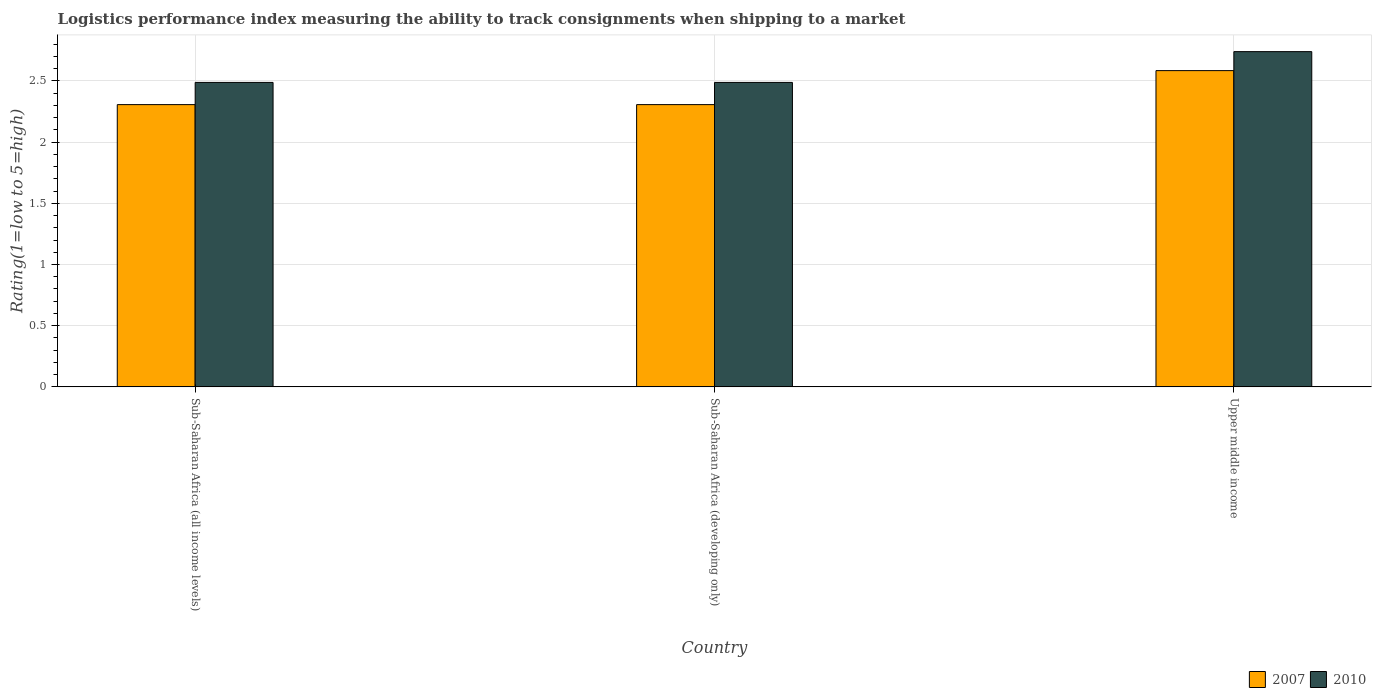How many groups of bars are there?
Make the answer very short. 3. What is the label of the 3rd group of bars from the left?
Your response must be concise. Upper middle income. In how many cases, is the number of bars for a given country not equal to the number of legend labels?
Keep it short and to the point. 0. What is the Logistic performance index in 2007 in Upper middle income?
Give a very brief answer. 2.58. Across all countries, what is the maximum Logistic performance index in 2007?
Offer a terse response. 2.58. Across all countries, what is the minimum Logistic performance index in 2010?
Provide a succinct answer. 2.49. In which country was the Logistic performance index in 2007 maximum?
Your response must be concise. Upper middle income. In which country was the Logistic performance index in 2007 minimum?
Make the answer very short. Sub-Saharan Africa (all income levels). What is the total Logistic performance index in 2007 in the graph?
Keep it short and to the point. 7.2. What is the difference between the Logistic performance index in 2010 in Sub-Saharan Africa (all income levels) and that in Upper middle income?
Your answer should be very brief. -0.25. What is the difference between the Logistic performance index in 2010 in Upper middle income and the Logistic performance index in 2007 in Sub-Saharan Africa (developing only)?
Provide a succinct answer. 0.43. What is the average Logistic performance index in 2010 per country?
Give a very brief answer. 2.57. What is the difference between the Logistic performance index of/in 2010 and Logistic performance index of/in 2007 in Sub-Saharan Africa (all income levels)?
Provide a succinct answer. 0.18. In how many countries, is the Logistic performance index in 2007 greater than 1.5?
Your response must be concise. 3. What is the ratio of the Logistic performance index in 2010 in Sub-Saharan Africa (all income levels) to that in Upper middle income?
Make the answer very short. 0.91. Is the Logistic performance index in 2010 in Sub-Saharan Africa (developing only) less than that in Upper middle income?
Offer a very short reply. Yes. Is the difference between the Logistic performance index in 2010 in Sub-Saharan Africa (all income levels) and Upper middle income greater than the difference between the Logistic performance index in 2007 in Sub-Saharan Africa (all income levels) and Upper middle income?
Give a very brief answer. Yes. What is the difference between the highest and the second highest Logistic performance index in 2007?
Offer a terse response. 0.28. What is the difference between the highest and the lowest Logistic performance index in 2007?
Offer a very short reply. 0.28. In how many countries, is the Logistic performance index in 2010 greater than the average Logistic performance index in 2010 taken over all countries?
Keep it short and to the point. 1. Is the sum of the Logistic performance index in 2007 in Sub-Saharan Africa (all income levels) and Upper middle income greater than the maximum Logistic performance index in 2010 across all countries?
Ensure brevity in your answer.  Yes. What does the 2nd bar from the left in Upper middle income represents?
Offer a very short reply. 2010. What does the 1st bar from the right in Sub-Saharan Africa (developing only) represents?
Make the answer very short. 2010. How many bars are there?
Your answer should be compact. 6. Are all the bars in the graph horizontal?
Keep it short and to the point. No. How many countries are there in the graph?
Make the answer very short. 3. What is the difference between two consecutive major ticks on the Y-axis?
Keep it short and to the point. 0.5. Does the graph contain any zero values?
Provide a short and direct response. No. Does the graph contain grids?
Make the answer very short. Yes. How are the legend labels stacked?
Provide a succinct answer. Horizontal. What is the title of the graph?
Your answer should be compact. Logistics performance index measuring the ability to track consignments when shipping to a market. Does "1977" appear as one of the legend labels in the graph?
Provide a succinct answer. No. What is the label or title of the X-axis?
Your answer should be very brief. Country. What is the label or title of the Y-axis?
Keep it short and to the point. Rating(1=low to 5=high). What is the Rating(1=low to 5=high) in 2007 in Sub-Saharan Africa (all income levels)?
Provide a short and direct response. 2.31. What is the Rating(1=low to 5=high) in 2010 in Sub-Saharan Africa (all income levels)?
Keep it short and to the point. 2.49. What is the Rating(1=low to 5=high) of 2007 in Sub-Saharan Africa (developing only)?
Your answer should be compact. 2.31. What is the Rating(1=low to 5=high) in 2010 in Sub-Saharan Africa (developing only)?
Provide a succinct answer. 2.49. What is the Rating(1=low to 5=high) in 2007 in Upper middle income?
Give a very brief answer. 2.58. What is the Rating(1=low to 5=high) of 2010 in Upper middle income?
Your answer should be very brief. 2.74. Across all countries, what is the maximum Rating(1=low to 5=high) of 2007?
Give a very brief answer. 2.58. Across all countries, what is the maximum Rating(1=low to 5=high) of 2010?
Provide a short and direct response. 2.74. Across all countries, what is the minimum Rating(1=low to 5=high) in 2007?
Your answer should be compact. 2.31. Across all countries, what is the minimum Rating(1=low to 5=high) in 2010?
Your answer should be very brief. 2.49. What is the total Rating(1=low to 5=high) in 2007 in the graph?
Your response must be concise. 7.2. What is the total Rating(1=low to 5=high) in 2010 in the graph?
Give a very brief answer. 7.71. What is the difference between the Rating(1=low to 5=high) of 2007 in Sub-Saharan Africa (all income levels) and that in Sub-Saharan Africa (developing only)?
Provide a short and direct response. 0. What is the difference between the Rating(1=low to 5=high) in 2010 in Sub-Saharan Africa (all income levels) and that in Sub-Saharan Africa (developing only)?
Your answer should be compact. 0. What is the difference between the Rating(1=low to 5=high) in 2007 in Sub-Saharan Africa (all income levels) and that in Upper middle income?
Your response must be concise. -0.28. What is the difference between the Rating(1=low to 5=high) in 2010 in Sub-Saharan Africa (all income levels) and that in Upper middle income?
Offer a very short reply. -0.25. What is the difference between the Rating(1=low to 5=high) of 2007 in Sub-Saharan Africa (developing only) and that in Upper middle income?
Your response must be concise. -0.28. What is the difference between the Rating(1=low to 5=high) of 2010 in Sub-Saharan Africa (developing only) and that in Upper middle income?
Make the answer very short. -0.25. What is the difference between the Rating(1=low to 5=high) of 2007 in Sub-Saharan Africa (all income levels) and the Rating(1=low to 5=high) of 2010 in Sub-Saharan Africa (developing only)?
Offer a very short reply. -0.18. What is the difference between the Rating(1=low to 5=high) of 2007 in Sub-Saharan Africa (all income levels) and the Rating(1=low to 5=high) of 2010 in Upper middle income?
Make the answer very short. -0.43. What is the difference between the Rating(1=low to 5=high) of 2007 in Sub-Saharan Africa (developing only) and the Rating(1=low to 5=high) of 2010 in Upper middle income?
Your answer should be compact. -0.43. What is the average Rating(1=low to 5=high) of 2007 per country?
Keep it short and to the point. 2.4. What is the average Rating(1=low to 5=high) of 2010 per country?
Keep it short and to the point. 2.57. What is the difference between the Rating(1=low to 5=high) of 2007 and Rating(1=low to 5=high) of 2010 in Sub-Saharan Africa (all income levels)?
Provide a succinct answer. -0.18. What is the difference between the Rating(1=low to 5=high) in 2007 and Rating(1=low to 5=high) in 2010 in Sub-Saharan Africa (developing only)?
Your answer should be very brief. -0.18. What is the difference between the Rating(1=low to 5=high) of 2007 and Rating(1=low to 5=high) of 2010 in Upper middle income?
Offer a terse response. -0.16. What is the ratio of the Rating(1=low to 5=high) in 2007 in Sub-Saharan Africa (all income levels) to that in Sub-Saharan Africa (developing only)?
Provide a succinct answer. 1. What is the ratio of the Rating(1=low to 5=high) of 2010 in Sub-Saharan Africa (all income levels) to that in Sub-Saharan Africa (developing only)?
Your answer should be compact. 1. What is the ratio of the Rating(1=low to 5=high) of 2007 in Sub-Saharan Africa (all income levels) to that in Upper middle income?
Offer a terse response. 0.89. What is the ratio of the Rating(1=low to 5=high) in 2010 in Sub-Saharan Africa (all income levels) to that in Upper middle income?
Offer a very short reply. 0.91. What is the ratio of the Rating(1=low to 5=high) in 2007 in Sub-Saharan Africa (developing only) to that in Upper middle income?
Your answer should be compact. 0.89. What is the ratio of the Rating(1=low to 5=high) in 2010 in Sub-Saharan Africa (developing only) to that in Upper middle income?
Make the answer very short. 0.91. What is the difference between the highest and the second highest Rating(1=low to 5=high) in 2007?
Offer a terse response. 0.28. What is the difference between the highest and the second highest Rating(1=low to 5=high) in 2010?
Make the answer very short. 0.25. What is the difference between the highest and the lowest Rating(1=low to 5=high) of 2007?
Offer a terse response. 0.28. What is the difference between the highest and the lowest Rating(1=low to 5=high) of 2010?
Provide a short and direct response. 0.25. 